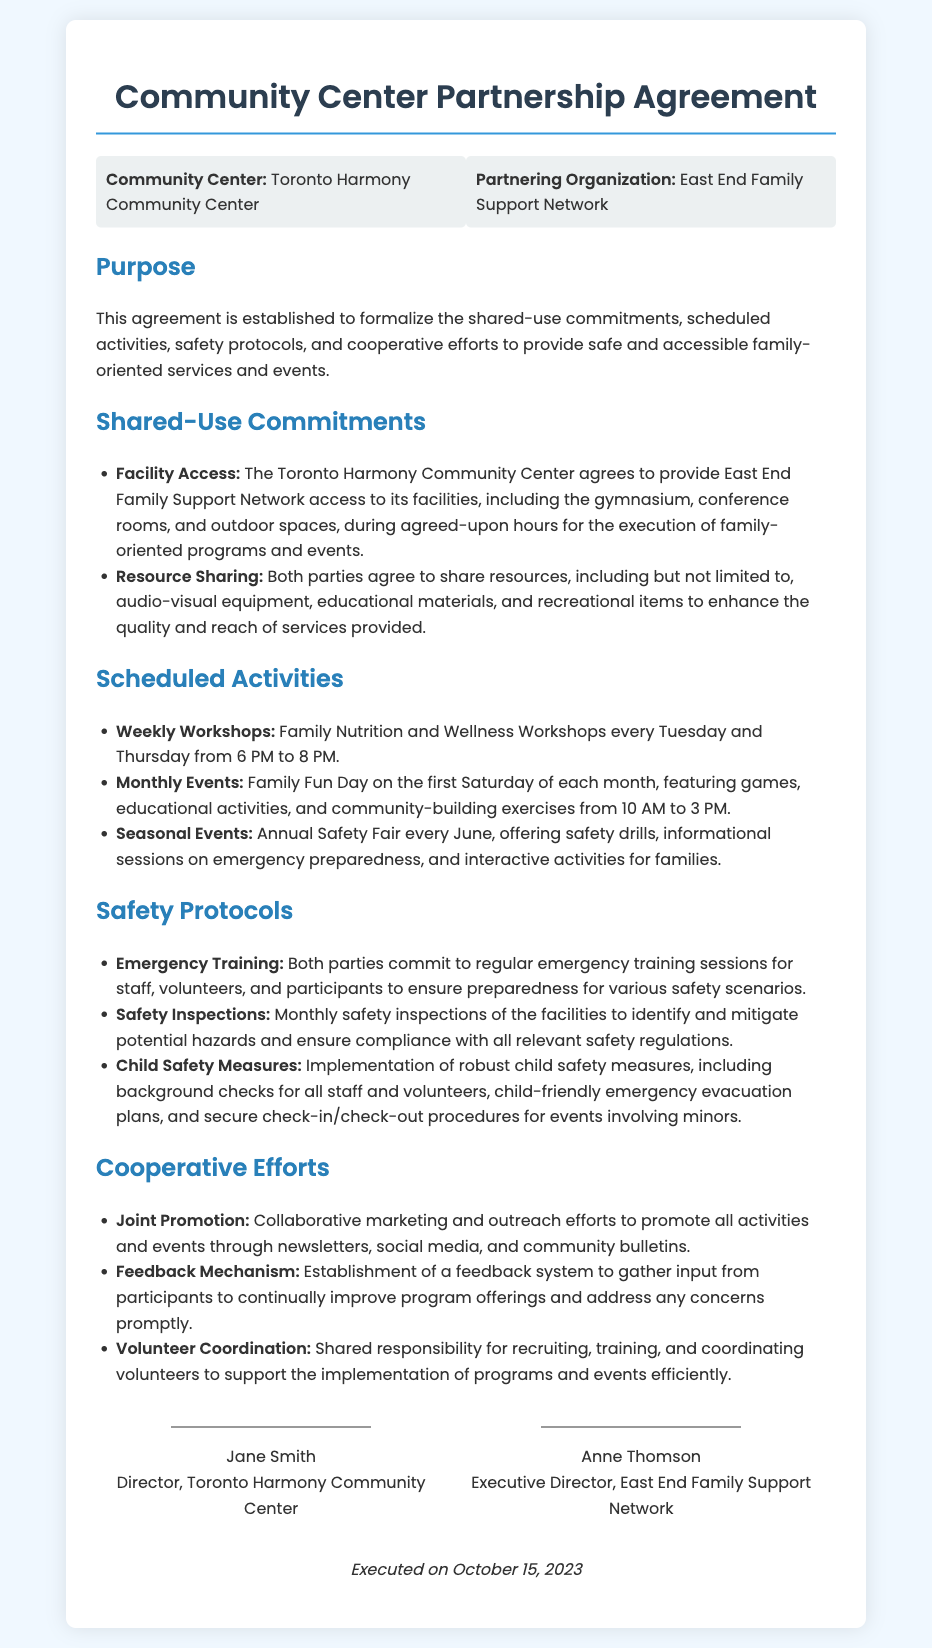what is the name of the community center? The name of the community center is mentioned in the header of the document, which states "Toronto Harmony Community Center."
Answer: Toronto Harmony Community Center who is the partnering organization? The partnering organization is listed in the document, identifying it as "East End Family Support Network."
Answer: East End Family Support Network what is the purpose of the agreement? The purpose of the agreement is stated in the introduction, which is to formalize the shared-use commitments, scheduled activities, safety protocols, and cooperative efforts.
Answer: Shared-use commitments, scheduled activities, safety protocols, and cooperative efforts how often do the Family Nutrition and Wellness Workshops occur? The document details the frequency of the Family Nutrition and Wellness Workshops occurring every Tuesday and Thursday.
Answer: Twice a week what month is the Annual Safety Fair held? The Annual Safety Fair is described as occurring every June in the document.
Answer: June what age group is specifically mentioned in the child safety measures? The child safety measures refer specifically to measures for "minors," indicating that they are focused on children.
Answer: Minors how often are safety inspections conducted according to the agreement? The document specifies that safety inspections are to be conducted monthly based on the safety protocols outlined.
Answer: Monthly what is one of the cooperative efforts mentioned in the document? The document lists several cooperative efforts, including "Joint Promotion" as one example of collaborative efforts between the parties.
Answer: Joint Promotion when was the agreement executed? The execution date of the agreement is clearly stated at the bottom of the document.
Answer: October 15, 2023 